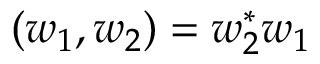<formula> <loc_0><loc_0><loc_500><loc_500>( w _ { 1 } , w _ { 2 } ) = w _ { 2 } ^ { * } w _ { 1 }</formula> 